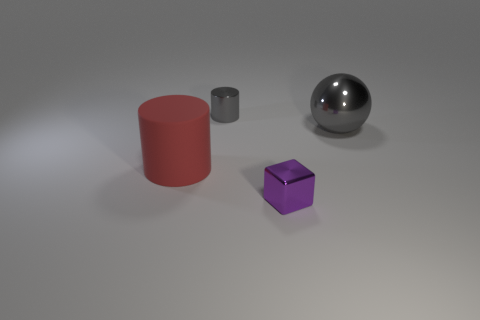There is a tiny object that is on the right side of the gray cylinder; what is its material?
Keep it short and to the point. Metal. Is the number of small gray shiny objects behind the small gray cylinder the same as the number of purple metallic cubes on the right side of the large cylinder?
Keep it short and to the point. No. There is a rubber thing that is the same shape as the small gray metal thing; what is its color?
Your answer should be very brief. Red. Is there any other thing that has the same color as the large ball?
Your answer should be very brief. Yes. What number of metallic objects are either large spheres or small purple things?
Provide a short and direct response. 2. Is the big sphere the same color as the tiny metallic cylinder?
Offer a very short reply. Yes. Are there more gray shiny things that are in front of the tiny gray thing than tiny green blocks?
Offer a terse response. Yes. How many other things are made of the same material as the purple object?
Make the answer very short. 2. What number of small objects are either red cylinders or gray metallic spheres?
Offer a very short reply. 0. Do the big red object and the small cylinder have the same material?
Offer a very short reply. No. 